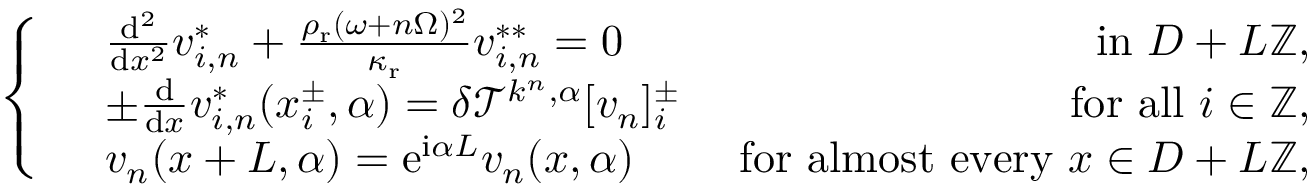<formula> <loc_0><loc_0><loc_500><loc_500>\left \{ \begin{array} { r l r } & { \frac { d ^ { 2 } } { d x ^ { 2 } } v _ { i , n } ^ { * } + \frac { \rho _ { r } ( \omega + n \Omega ) ^ { 2 } } { \kappa _ { r } } v _ { i , n } ^ { * * } = 0 } & { i n D + L \mathbb { Z } , } \\ & { \pm \frac { d } { d x } v _ { i , n } ^ { * } ( x _ { i } ^ { \pm } , \alpha ) = \delta \mathcal { T } ^ { k ^ { n } , \alpha } [ v _ { n } ] _ { i } ^ { \pm } } & { f o r a l l i \in \mathbb { Z } , } \\ & { v _ { n } ( x + L , \alpha ) = e ^ { i \alpha L } v _ { n } ( x , \alpha ) } & { f o r a l m o s t e v e r y x \in D + L \mathbb { Z } , } \end{array}</formula> 